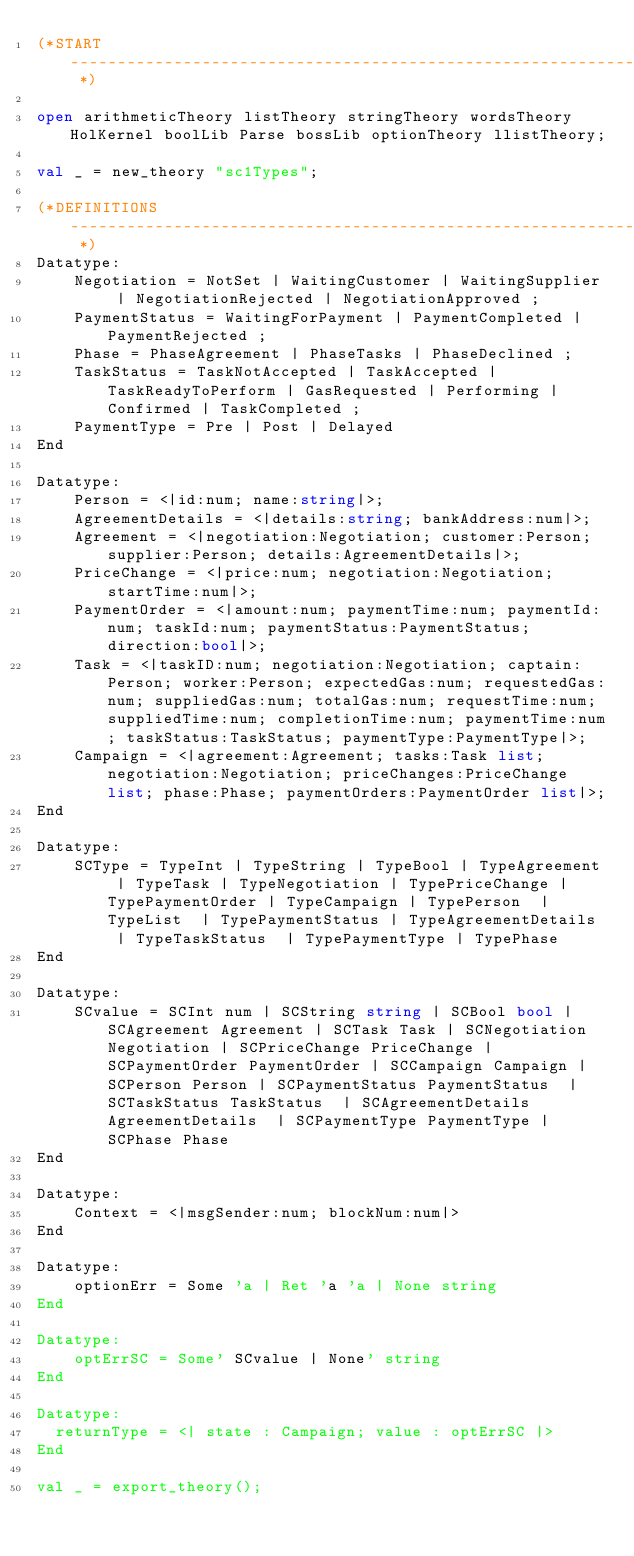Convert code to text. <code><loc_0><loc_0><loc_500><loc_500><_SML_>(*START ------------------------------------------------------------------------- *)

open arithmeticTheory listTheory stringTheory wordsTheory HolKernel boolLib Parse bossLib optionTheory llistTheory;

val _ = new_theory "sc1Types";

(*DEFINITIONS ------------------------------------------------------------------- *)
Datatype:
    Negotiation = NotSet | WaitingCustomer | WaitingSupplier | NegotiationRejected | NegotiationApproved ;
    PaymentStatus = WaitingForPayment | PaymentCompleted | PaymentRejected ;
    Phase = PhaseAgreement | PhaseTasks | PhaseDeclined ;
    TaskStatus = TaskNotAccepted | TaskAccepted | TaskReadyToPerform | GasRequested | Performing | Confirmed | TaskCompleted ;
    PaymentType = Pre | Post | Delayed
End

Datatype:
    Person = <|id:num; name:string|>;
    AgreementDetails = <|details:string; bankAddress:num|>;
    Agreement = <|negotiation:Negotiation; customer:Person; supplier:Person; details:AgreementDetails|>;
    PriceChange = <|price:num; negotiation:Negotiation; startTime:num|>;
    PaymentOrder = <|amount:num; paymentTime:num; paymentId:num; taskId:num; paymentStatus:PaymentStatus; direction:bool|>;
    Task = <|taskID:num; negotiation:Negotiation; captain:Person; worker:Person; expectedGas:num; requestedGas:num; suppliedGas:num; totalGas:num; requestTime:num; suppliedTime:num; completionTime:num; paymentTime:num; taskStatus:TaskStatus; paymentType:PaymentType|>;
    Campaign = <|agreement:Agreement; tasks:Task list; negotiation:Negotiation; priceChanges:PriceChange list; phase:Phase; paymentOrders:PaymentOrder list|>;
End

Datatype:
    SCType = TypeInt | TypeString | TypeBool | TypeAgreement | TypeTask | TypeNegotiation | TypePriceChange | TypePaymentOrder | TypeCampaign | TypePerson  | TypeList  | TypePaymentStatus | TypeAgreementDetails  | TypeTaskStatus  | TypePaymentType | TypePhase
End

Datatype:
    SCvalue = SCInt num | SCString string | SCBool bool | SCAgreement Agreement | SCTask Task | SCNegotiation Negotiation | SCPriceChange PriceChange | SCPaymentOrder PaymentOrder | SCCampaign Campaign | SCPerson Person | SCPaymentStatus PaymentStatus  | SCTaskStatus TaskStatus  | SCAgreementDetails AgreementDetails  | SCPaymentType PaymentType | SCPhase Phase
End

Datatype:
    Context = <|msgSender:num; blockNum:num|>
End

Datatype:
    optionErr = Some 'a | Ret 'a 'a | None string
End

Datatype:
    optErrSC = Some' SCvalue | None' string
End

Datatype:
  returnType = <| state : Campaign; value : optErrSC |>
End

val _ = export_theory();
</code> 